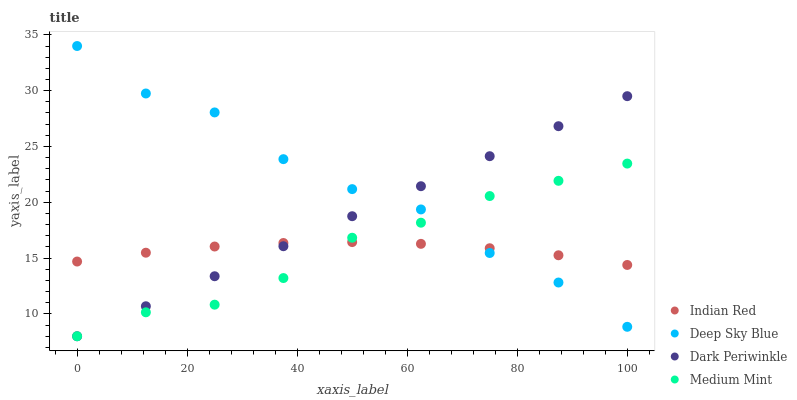Does Indian Red have the minimum area under the curve?
Answer yes or no. Yes. Does Deep Sky Blue have the maximum area under the curve?
Answer yes or no. Yes. Does Deep Sky Blue have the minimum area under the curve?
Answer yes or no. No. Does Indian Red have the maximum area under the curve?
Answer yes or no. No. Is Dark Periwinkle the smoothest?
Answer yes or no. Yes. Is Deep Sky Blue the roughest?
Answer yes or no. Yes. Is Indian Red the smoothest?
Answer yes or no. No. Is Indian Red the roughest?
Answer yes or no. No. Does Medium Mint have the lowest value?
Answer yes or no. Yes. Does Deep Sky Blue have the lowest value?
Answer yes or no. No. Does Deep Sky Blue have the highest value?
Answer yes or no. Yes. Does Indian Red have the highest value?
Answer yes or no. No. Does Deep Sky Blue intersect Indian Red?
Answer yes or no. Yes. Is Deep Sky Blue less than Indian Red?
Answer yes or no. No. Is Deep Sky Blue greater than Indian Red?
Answer yes or no. No. 